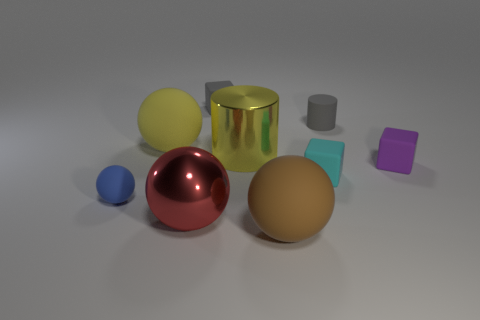Subtract all brown spheres. How many spheres are left? 3 Add 1 big yellow rubber objects. How many objects exist? 10 Subtract all cubes. How many objects are left? 6 Subtract all gray cubes. How many cubes are left? 2 Subtract 4 spheres. How many spheres are left? 0 Add 1 tiny blue matte objects. How many tiny blue matte objects are left? 2 Add 3 big brown matte spheres. How many big brown matte spheres exist? 4 Subtract 0 gray spheres. How many objects are left? 9 Subtract all blue cylinders. Subtract all purple cubes. How many cylinders are left? 2 Subtract all red objects. Subtract all big metallic cylinders. How many objects are left? 7 